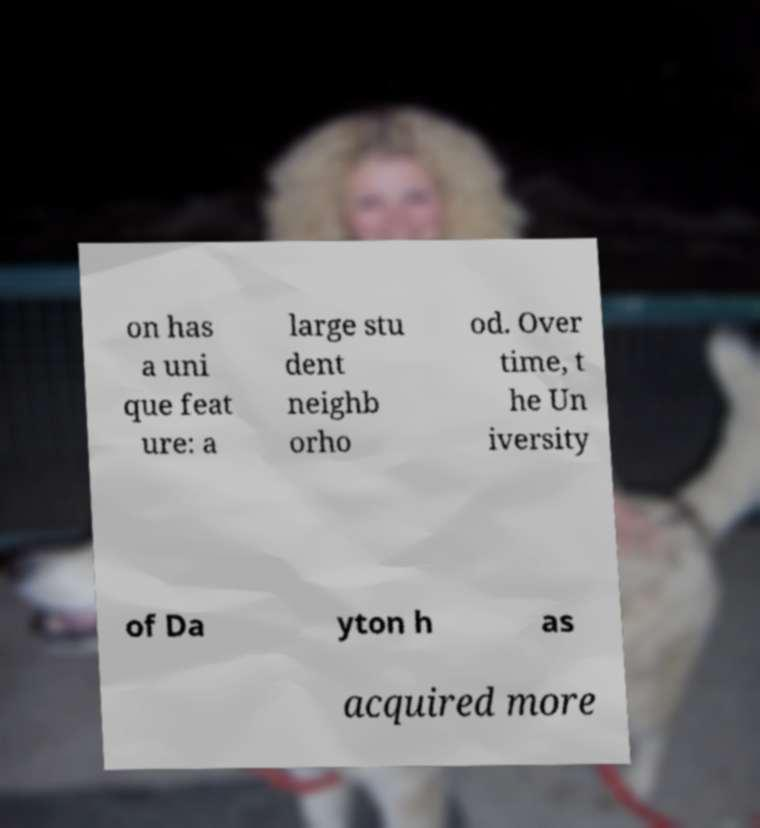There's text embedded in this image that I need extracted. Can you transcribe it verbatim? on has a uni que feat ure: a large stu dent neighb orho od. Over time, t he Un iversity of Da yton h as acquired more 